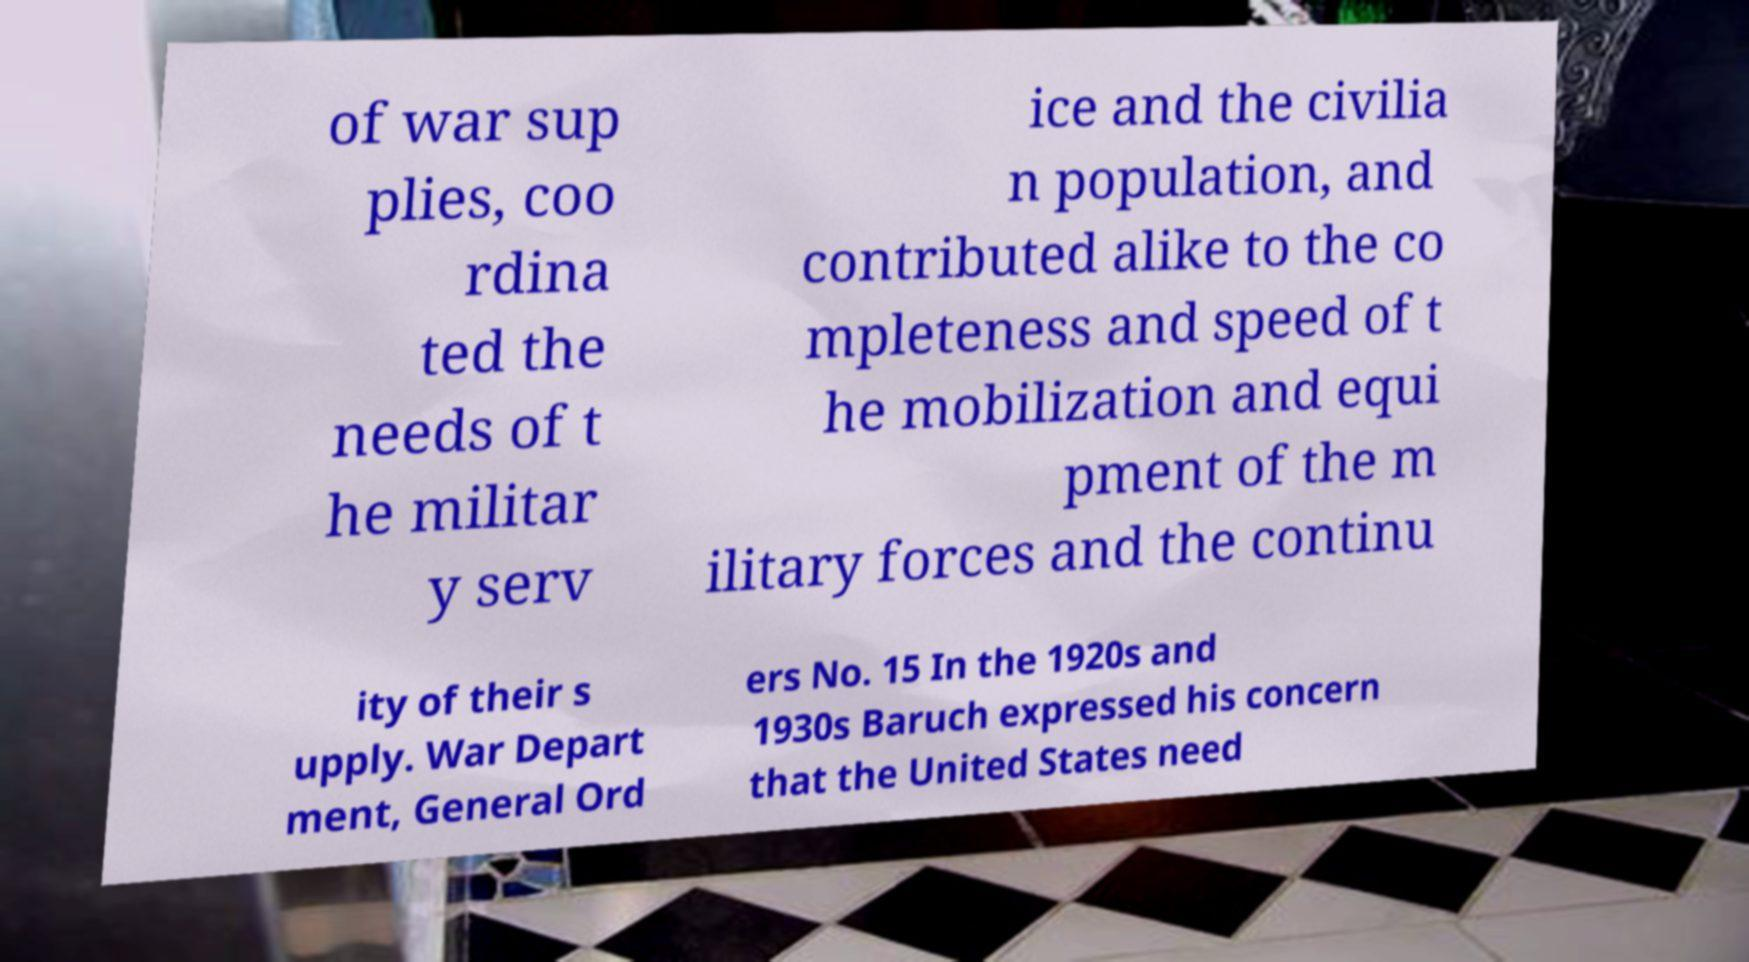Can you read and provide the text displayed in the image?This photo seems to have some interesting text. Can you extract and type it out for me? of war sup plies, coo rdina ted the needs of t he militar y serv ice and the civilia n population, and contributed alike to the co mpleteness and speed of t he mobilization and equi pment of the m ilitary forces and the continu ity of their s upply. War Depart ment, General Ord ers No. 15 In the 1920s and 1930s Baruch expressed his concern that the United States need 